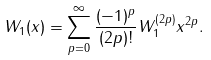<formula> <loc_0><loc_0><loc_500><loc_500>W _ { 1 } ( x ) = \sum _ { p = 0 } ^ { \infty } \frac { ( - 1 ) ^ { p } } { ( 2 p ) ! } W _ { 1 } ^ { ( 2 p ) } x ^ { 2 p } .</formula> 